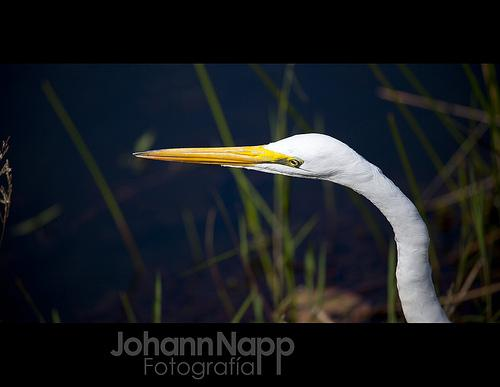Question: how many birds?
Choices:
A. 2.
B. 3.
C. 1.
D. 4.
Answer with the letter. Answer: C Question: what is white?
Choices:
A. Dog.
B. Cat.
C. Mouse.
D. Bird.
Answer with the letter. Answer: D Question: where are the words?
Choices:
A. Bottom.
B. Top.
C. Side.
D. Back.
Answer with the letter. Answer: A Question: what is yellow?
Choices:
A. Feet.
B. Feathers.
C. Head.
D. Beak.
Answer with the letter. Answer: D 